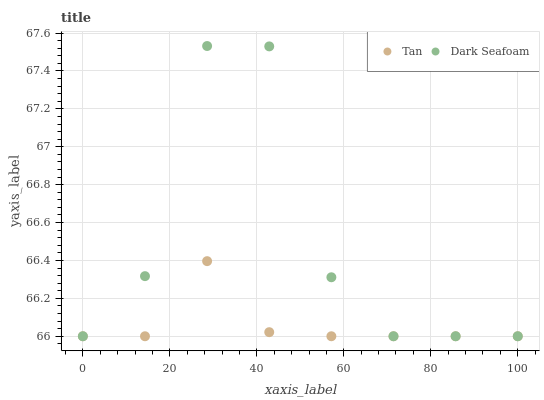Does Tan have the minimum area under the curve?
Answer yes or no. Yes. Does Dark Seafoam have the maximum area under the curve?
Answer yes or no. Yes. Does Dark Seafoam have the minimum area under the curve?
Answer yes or no. No. Is Tan the smoothest?
Answer yes or no. Yes. Is Dark Seafoam the roughest?
Answer yes or no. Yes. Is Dark Seafoam the smoothest?
Answer yes or no. No. Does Tan have the lowest value?
Answer yes or no. Yes. Does Dark Seafoam have the highest value?
Answer yes or no. Yes. Does Dark Seafoam intersect Tan?
Answer yes or no. Yes. Is Dark Seafoam less than Tan?
Answer yes or no. No. Is Dark Seafoam greater than Tan?
Answer yes or no. No. 